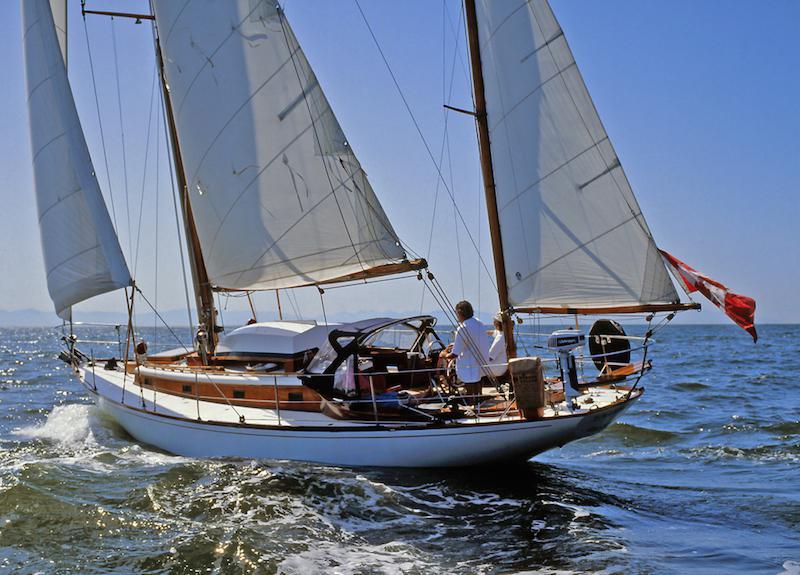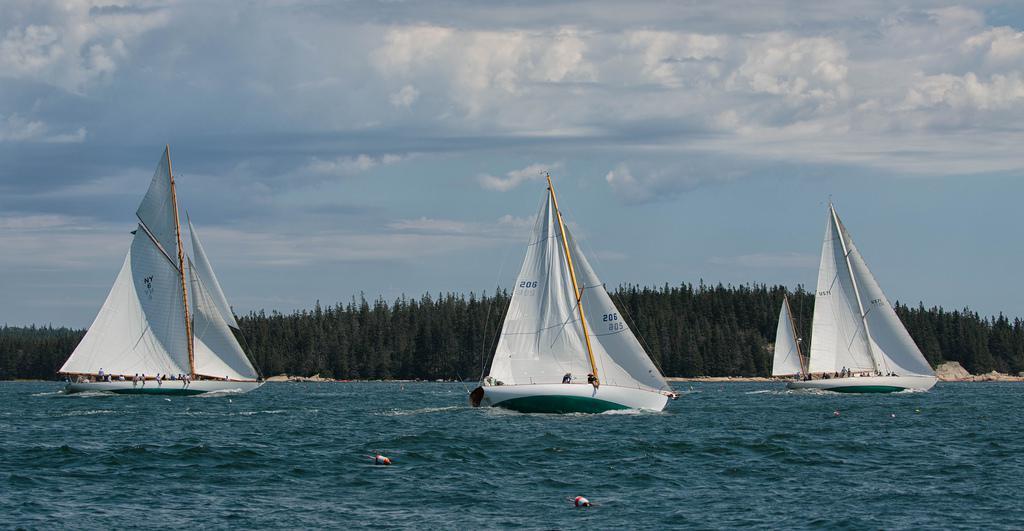The first image is the image on the left, the second image is the image on the right. Considering the images on both sides, is "There are more boats in the image on the right than the image on the left." valid? Answer yes or no. Yes. The first image is the image on the left, the second image is the image on the right. For the images shown, is this caption "An image shows multiple sailboats with unfurled sails." true? Answer yes or no. Yes. 